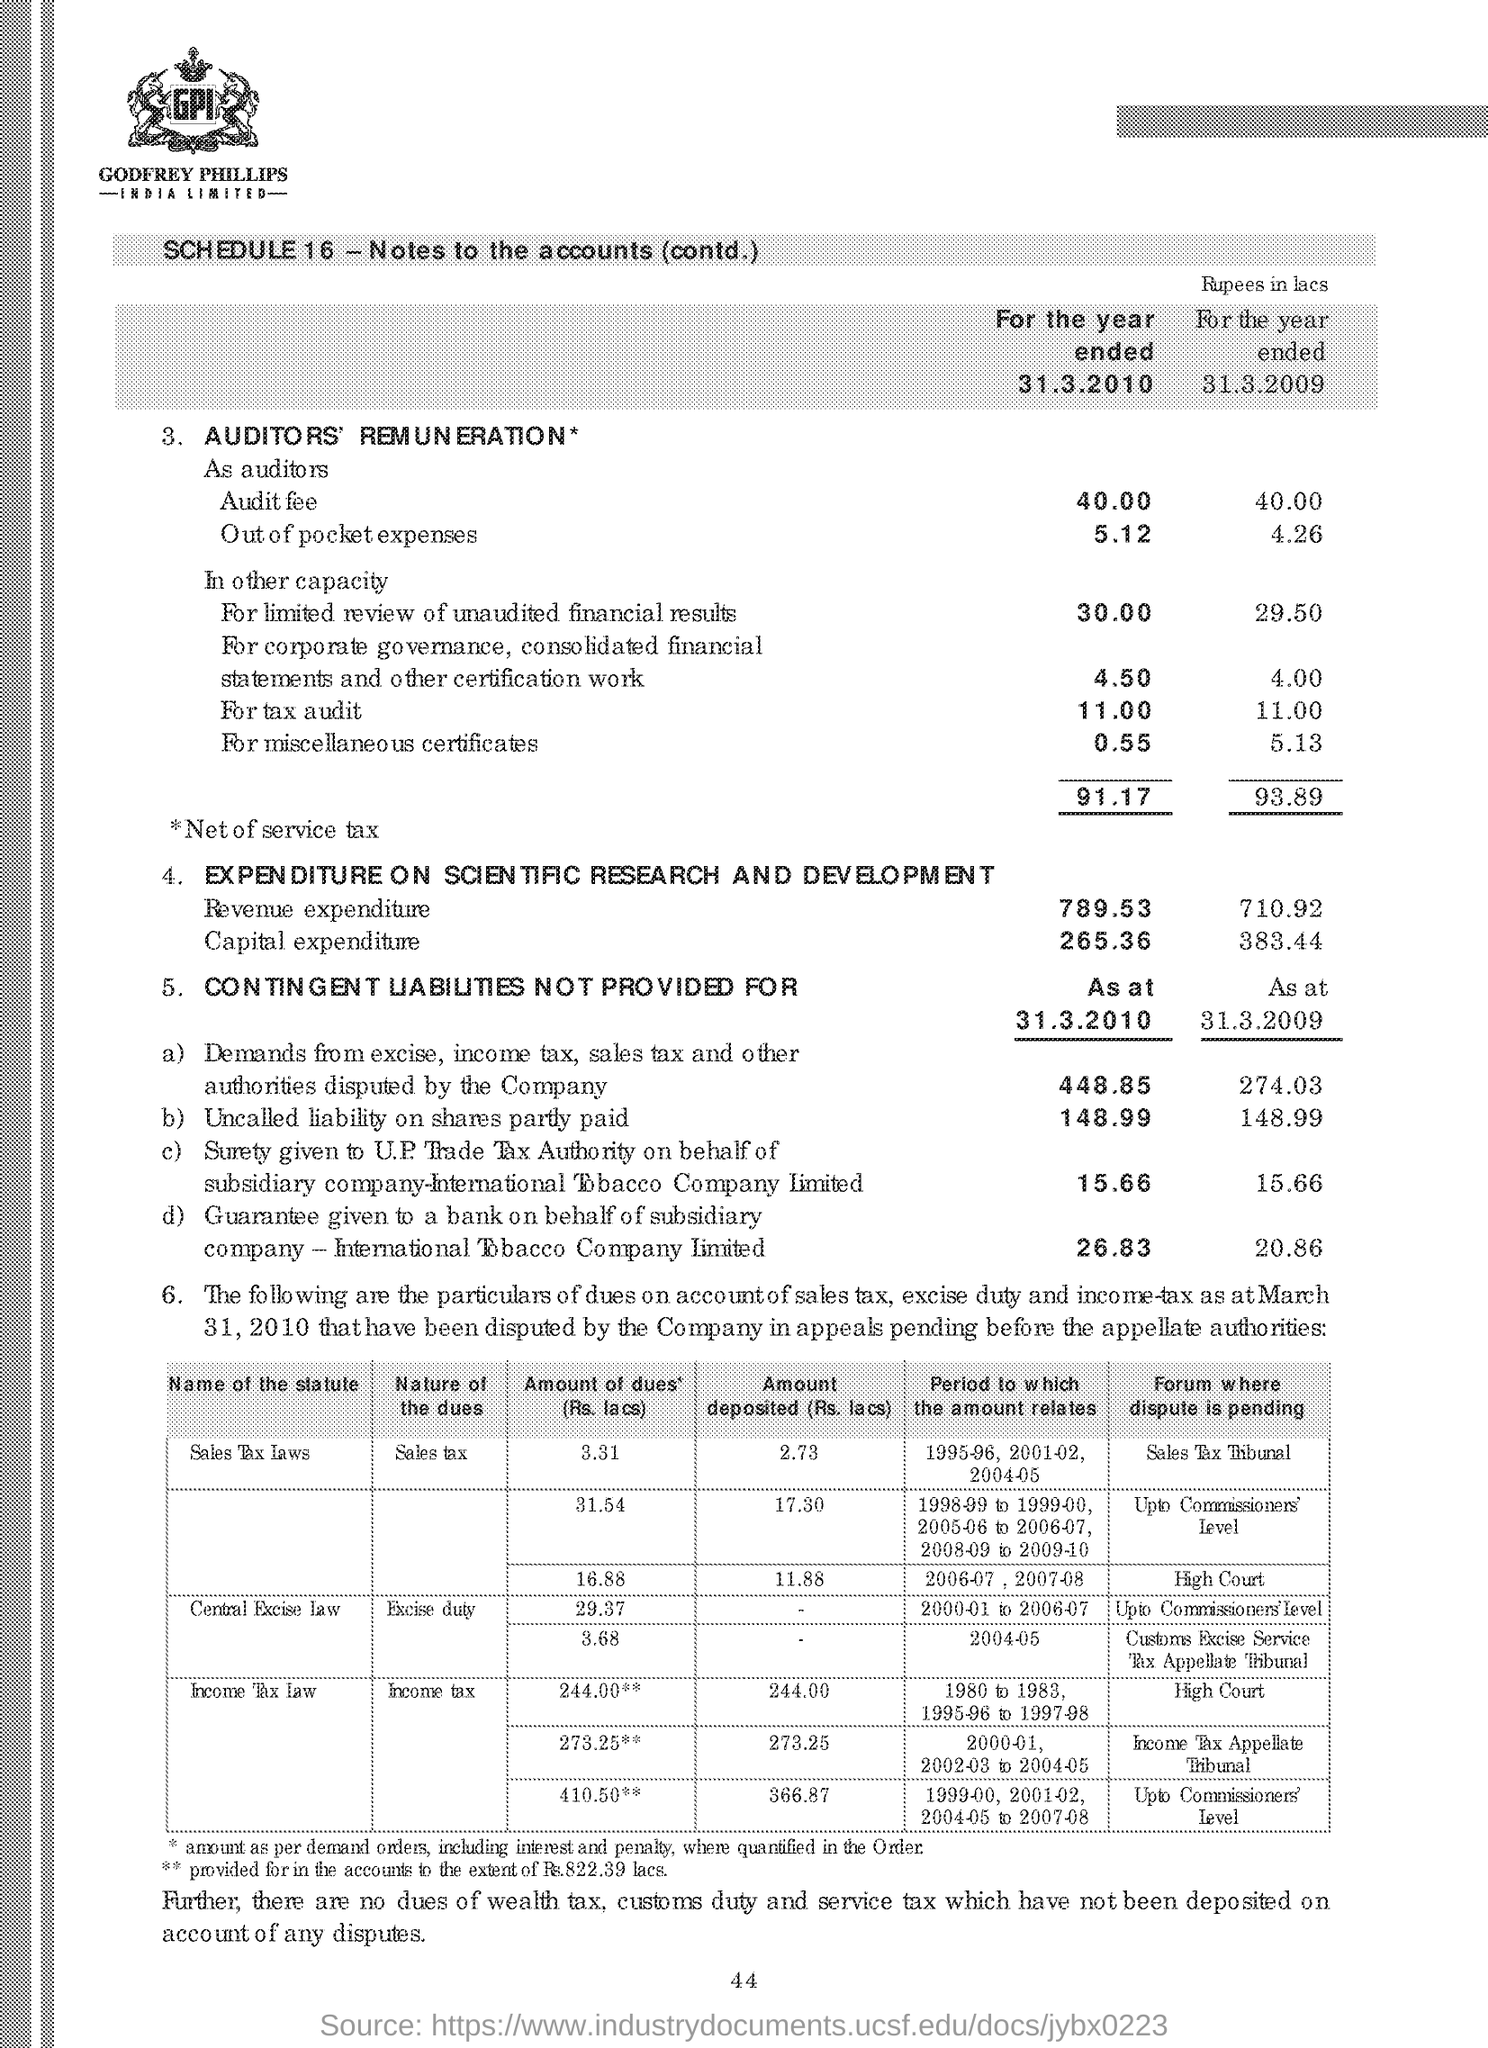Draw attention to some important aspects in this diagram. Excise duty is a type of tax imposed by the central government on goods produced or manufactured in India. The nature of excise duty is outlined in the Central Excise Law, which governs the levy, collection, and recovery of excise duty on goods. The number written at the bottom of the document is 44. 